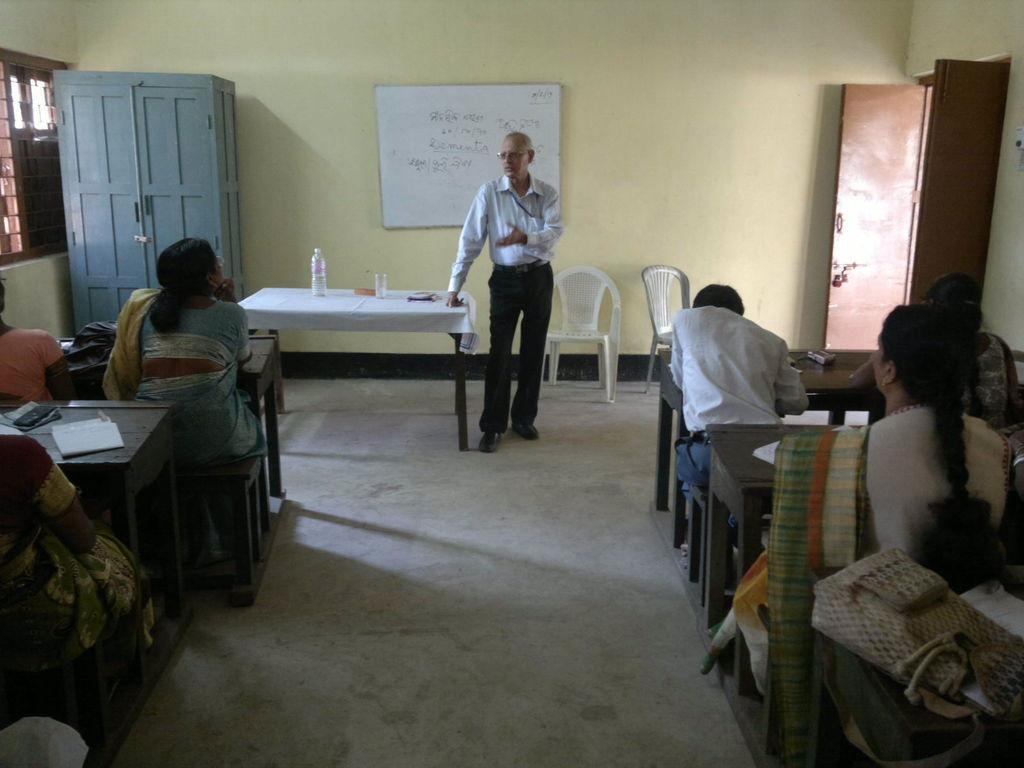Please provide a concise description of this image. On both side of the image, there are group of people sitting on the bench. In the middle, a person is standing and talking. Next to that a table on which bottle and glass is kept. The background wall is yellow in color. In the left top, a cupboard is there and a window is visible. On the right, a door is visible. This image is taken inside a room. 